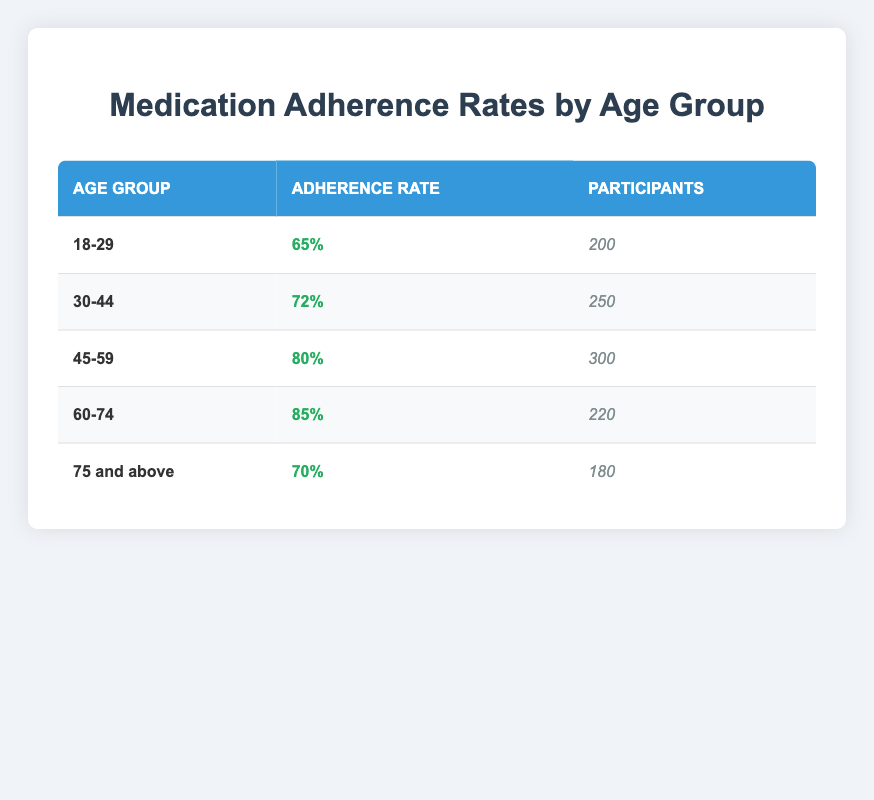What is the medication adherence rate for the age group 45-59? The table directly shows that the adherence rate for the age group 45-59 is 80%.
Answer: 80% How many participants are there in the age group 60-74? The table specifies that there are 220 participants in the age group 60-74.
Answer: 220 Is the adherence rate for those aged 30-44 higher than that for those aged 75 and above? According to the table, the adherence rate for those aged 30-44 is 72%, and for those 75 and above, it is 70%. Since 72% is greater than 70%, the statement is true.
Answer: Yes What is the average adherence rate across all age groups? To calculate the average adherence rate, we add all adherence rates: (65% + 72% + 80% + 85% + 70%) = 372%. There are 5 age groups, so we divide 372% by 5: 372% / 5 = 74.4%.
Answer: 74.4% How many total participants were surveyed across all age groups? The total number of participants is the sum of participants from each age group: 200 + 250 + 300 + 220 + 180 = 1150.
Answer: 1150 Is the adherence rate of the youngest age group (18-29) lower than that of the oldest group (75 and above)? The adherence rate for the 18-29 age group is 65%, and for the 75 and above group, it is 70%. Since 65% is less than 70%, the statement is true.
Answer: Yes Which age group has the highest medication adherence rate? The age group 60-74 has the highest adherence rate at 85%, as indicated in the table.
Answer: 60-74 What is the difference in adherence rates between the age groups 45-59 and 30-44? The adherence rate for 45-59 is 80% and for 30-44, it is 72%. To find the difference: 80% - 72% = 8%.
Answer: 8% 